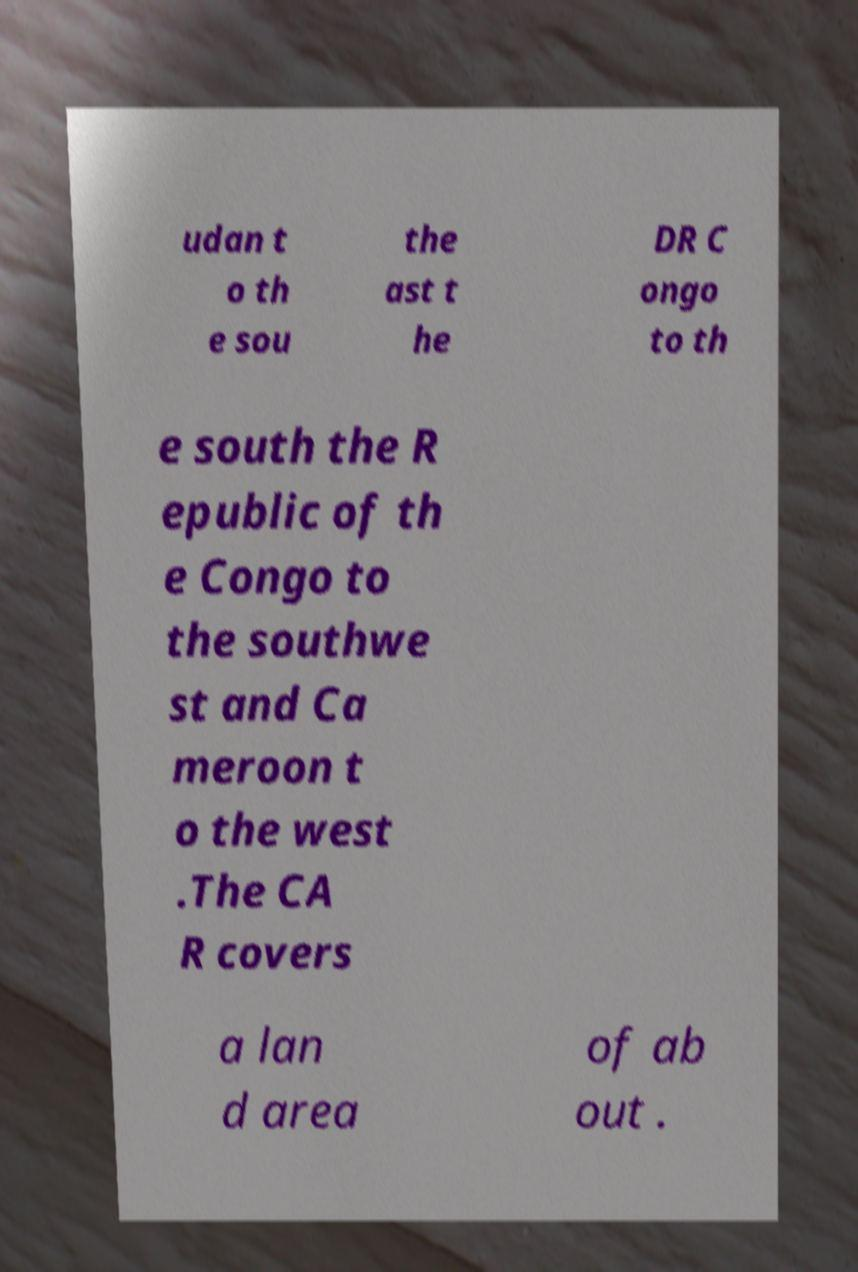Can you accurately transcribe the text from the provided image for me? udan t o th e sou the ast t he DR C ongo to th e south the R epublic of th e Congo to the southwe st and Ca meroon t o the west .The CA R covers a lan d area of ab out . 